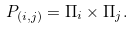Convert formula to latex. <formula><loc_0><loc_0><loc_500><loc_500>P _ { ( i , j ) } = \Pi _ { i } \times \Pi _ { j } .</formula> 